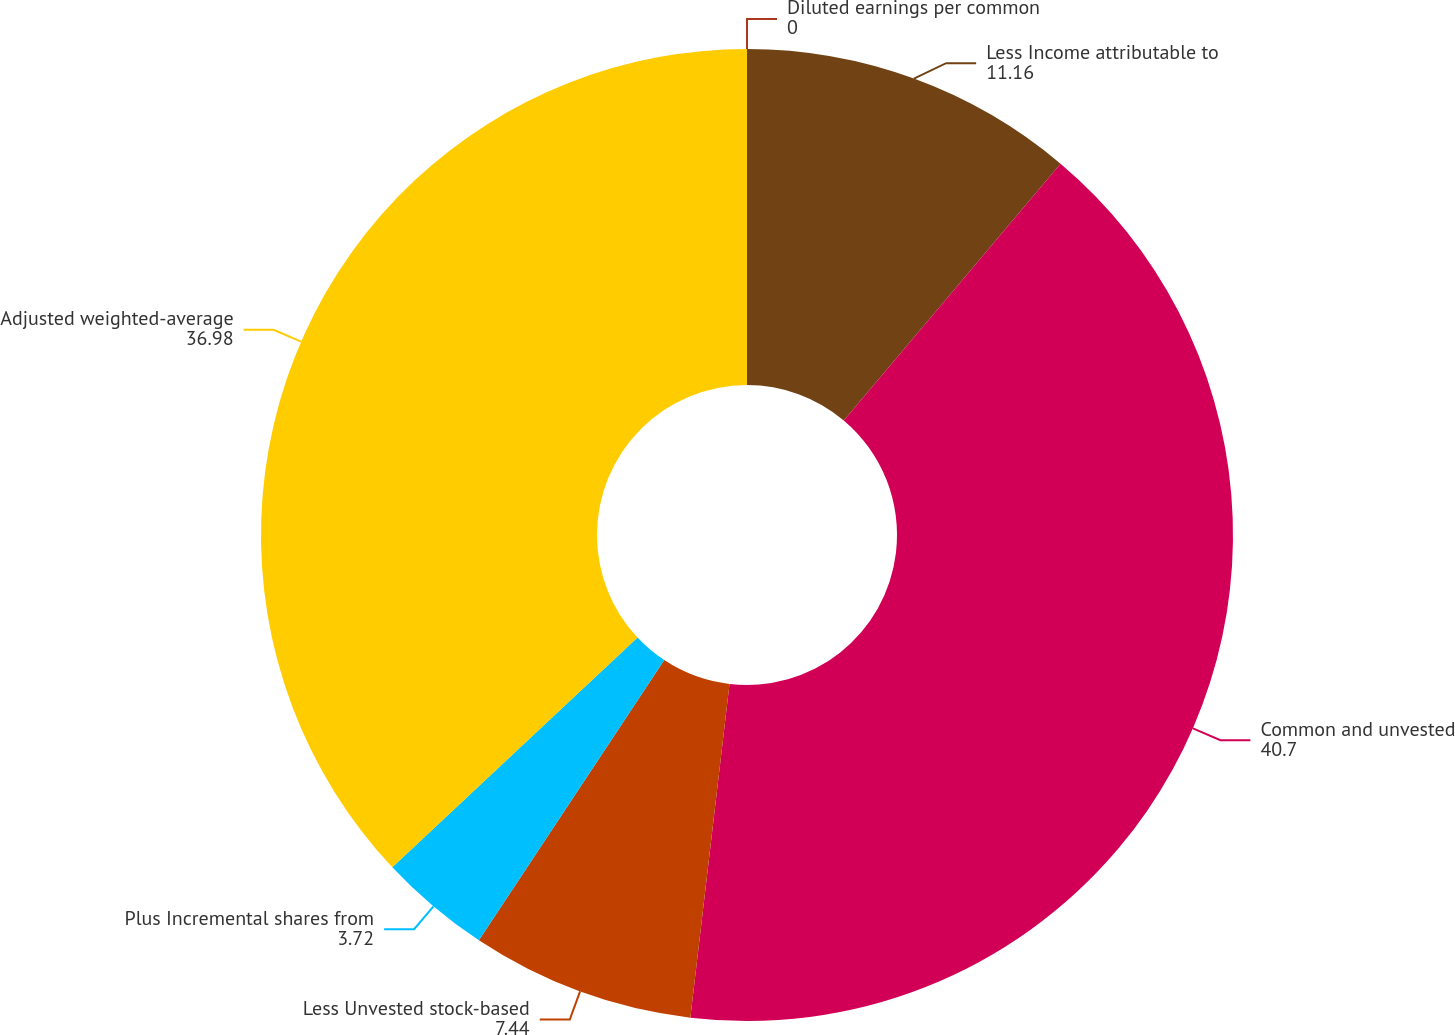Convert chart. <chart><loc_0><loc_0><loc_500><loc_500><pie_chart><fcel>Less Income attributable to<fcel>Common and unvested<fcel>Less Unvested stock-based<fcel>Plus Incremental shares from<fcel>Adjusted weighted-average<fcel>Diluted earnings per common<nl><fcel>11.16%<fcel>40.7%<fcel>7.44%<fcel>3.72%<fcel>36.98%<fcel>0.0%<nl></chart> 